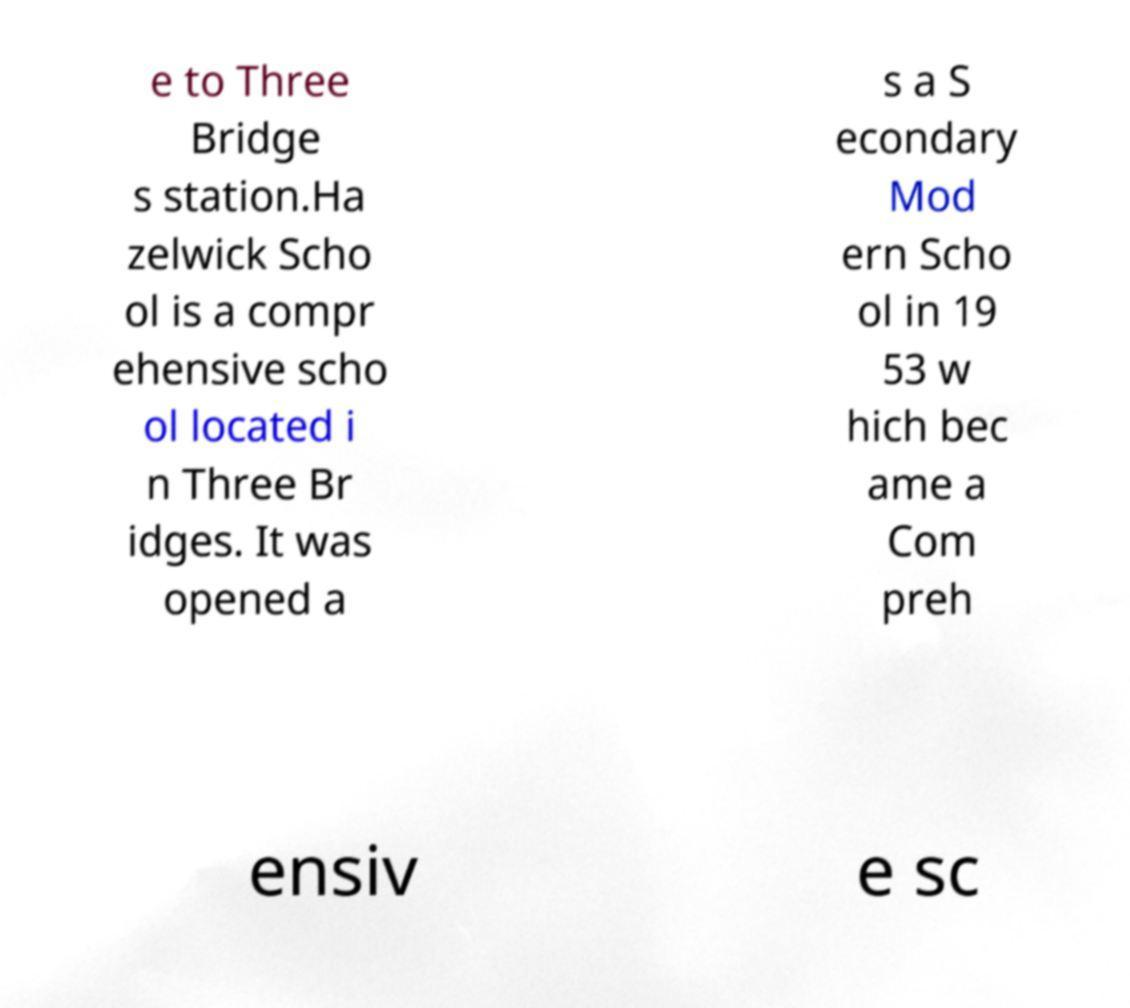Could you extract and type out the text from this image? e to Three Bridge s station.Ha zelwick Scho ol is a compr ehensive scho ol located i n Three Br idges. It was opened a s a S econdary Mod ern Scho ol in 19 53 w hich bec ame a Com preh ensiv e sc 